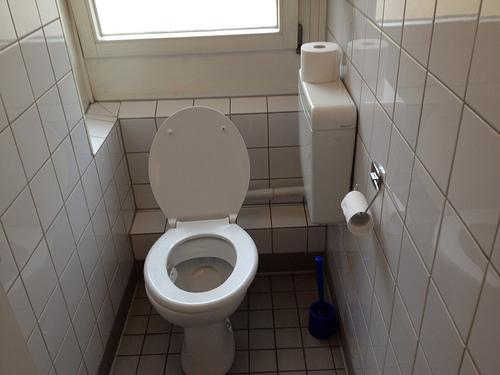Question: who is in the picture?
Choices:
A. Mary.
B. Albert.
C. No one.
D. Thomas.
Answer with the letter. Answer: C Question: what color are the tiles?
Choices:
A. Black.
B. White.
C. Brown.
D. Orange.
Answer with the letter. Answer: B Question: how many toilet paper rolls are in the picture?
Choices:
A. One.
B. Two.
C. Four.
D. Three.
Answer with the letter. Answer: B Question: where was this picture taken?
Choices:
A. Bathroom.
B. Upstairs.
C. Kitchen.
D. Living room.
Answer with the letter. Answer: A 